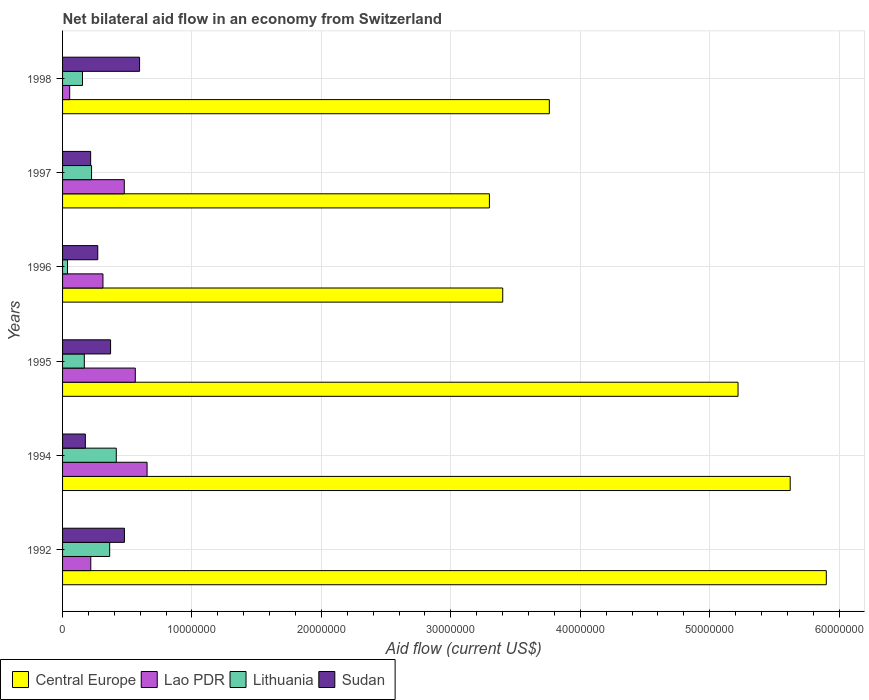How many different coloured bars are there?
Your answer should be compact. 4. How many bars are there on the 2nd tick from the bottom?
Provide a succinct answer. 4. What is the label of the 2nd group of bars from the top?
Offer a very short reply. 1997. In how many cases, is the number of bars for a given year not equal to the number of legend labels?
Provide a succinct answer. 0. What is the net bilateral aid flow in Lao PDR in 1992?
Your answer should be very brief. 2.18e+06. Across all years, what is the maximum net bilateral aid flow in Lithuania?
Provide a short and direct response. 4.15e+06. Across all years, what is the minimum net bilateral aid flow in Lithuania?
Provide a short and direct response. 3.80e+05. In which year was the net bilateral aid flow in Central Europe minimum?
Your answer should be compact. 1997. What is the total net bilateral aid flow in Lithuania in the graph?
Your answer should be very brief. 1.36e+07. What is the difference between the net bilateral aid flow in Sudan in 1992 and that in 1994?
Your answer should be compact. 3.02e+06. What is the difference between the net bilateral aid flow in Sudan in 1992 and the net bilateral aid flow in Lithuania in 1998?
Offer a very short reply. 3.24e+06. What is the average net bilateral aid flow in Central Europe per year?
Your answer should be compact. 4.53e+07. In the year 1996, what is the difference between the net bilateral aid flow in Sudan and net bilateral aid flow in Central Europe?
Provide a succinct answer. -3.13e+07. What is the ratio of the net bilateral aid flow in Lithuania in 1996 to that in 1998?
Your answer should be compact. 0.25. Is the net bilateral aid flow in Lithuania in 1997 less than that in 1998?
Your answer should be compact. No. What is the difference between the highest and the second highest net bilateral aid flow in Lao PDR?
Ensure brevity in your answer.  9.10e+05. What is the difference between the highest and the lowest net bilateral aid flow in Lao PDR?
Keep it short and to the point. 5.98e+06. Is the sum of the net bilateral aid flow in Lao PDR in 1995 and 1997 greater than the maximum net bilateral aid flow in Sudan across all years?
Your answer should be very brief. Yes. What does the 3rd bar from the top in 1997 represents?
Provide a short and direct response. Lao PDR. What does the 3rd bar from the bottom in 1996 represents?
Keep it short and to the point. Lithuania. How many bars are there?
Give a very brief answer. 24. What is the difference between two consecutive major ticks on the X-axis?
Keep it short and to the point. 1.00e+07. Are the values on the major ticks of X-axis written in scientific E-notation?
Make the answer very short. No. Does the graph contain grids?
Your answer should be very brief. Yes. What is the title of the graph?
Your answer should be compact. Net bilateral aid flow in an economy from Switzerland. What is the label or title of the X-axis?
Keep it short and to the point. Aid flow (current US$). What is the Aid flow (current US$) in Central Europe in 1992?
Offer a terse response. 5.90e+07. What is the Aid flow (current US$) in Lao PDR in 1992?
Your answer should be very brief. 2.18e+06. What is the Aid flow (current US$) of Lithuania in 1992?
Give a very brief answer. 3.64e+06. What is the Aid flow (current US$) of Sudan in 1992?
Offer a terse response. 4.78e+06. What is the Aid flow (current US$) of Central Europe in 1994?
Offer a very short reply. 5.62e+07. What is the Aid flow (current US$) of Lao PDR in 1994?
Your answer should be compact. 6.53e+06. What is the Aid flow (current US$) of Lithuania in 1994?
Your response must be concise. 4.15e+06. What is the Aid flow (current US$) of Sudan in 1994?
Your answer should be very brief. 1.76e+06. What is the Aid flow (current US$) in Central Europe in 1995?
Make the answer very short. 5.22e+07. What is the Aid flow (current US$) of Lao PDR in 1995?
Provide a short and direct response. 5.62e+06. What is the Aid flow (current US$) of Lithuania in 1995?
Provide a short and direct response. 1.68e+06. What is the Aid flow (current US$) in Sudan in 1995?
Offer a very short reply. 3.71e+06. What is the Aid flow (current US$) of Central Europe in 1996?
Provide a short and direct response. 3.40e+07. What is the Aid flow (current US$) of Lao PDR in 1996?
Keep it short and to the point. 3.12e+06. What is the Aid flow (current US$) in Lithuania in 1996?
Offer a terse response. 3.80e+05. What is the Aid flow (current US$) in Sudan in 1996?
Your answer should be very brief. 2.72e+06. What is the Aid flow (current US$) in Central Europe in 1997?
Provide a succinct answer. 3.30e+07. What is the Aid flow (current US$) of Lao PDR in 1997?
Provide a short and direct response. 4.77e+06. What is the Aid flow (current US$) in Lithuania in 1997?
Make the answer very short. 2.24e+06. What is the Aid flow (current US$) of Sudan in 1997?
Give a very brief answer. 2.17e+06. What is the Aid flow (current US$) of Central Europe in 1998?
Your answer should be very brief. 3.76e+07. What is the Aid flow (current US$) of Lithuania in 1998?
Offer a very short reply. 1.54e+06. What is the Aid flow (current US$) of Sudan in 1998?
Give a very brief answer. 5.95e+06. Across all years, what is the maximum Aid flow (current US$) in Central Europe?
Provide a succinct answer. 5.90e+07. Across all years, what is the maximum Aid flow (current US$) in Lao PDR?
Provide a succinct answer. 6.53e+06. Across all years, what is the maximum Aid flow (current US$) of Lithuania?
Your response must be concise. 4.15e+06. Across all years, what is the maximum Aid flow (current US$) of Sudan?
Give a very brief answer. 5.95e+06. Across all years, what is the minimum Aid flow (current US$) in Central Europe?
Your answer should be very brief. 3.30e+07. Across all years, what is the minimum Aid flow (current US$) of Lithuania?
Make the answer very short. 3.80e+05. Across all years, what is the minimum Aid flow (current US$) of Sudan?
Give a very brief answer. 1.76e+06. What is the total Aid flow (current US$) of Central Europe in the graph?
Your response must be concise. 2.72e+08. What is the total Aid flow (current US$) in Lao PDR in the graph?
Your answer should be compact. 2.28e+07. What is the total Aid flow (current US$) of Lithuania in the graph?
Your answer should be compact. 1.36e+07. What is the total Aid flow (current US$) in Sudan in the graph?
Your answer should be very brief. 2.11e+07. What is the difference between the Aid flow (current US$) of Central Europe in 1992 and that in 1994?
Keep it short and to the point. 2.79e+06. What is the difference between the Aid flow (current US$) in Lao PDR in 1992 and that in 1994?
Provide a succinct answer. -4.35e+06. What is the difference between the Aid flow (current US$) of Lithuania in 1992 and that in 1994?
Give a very brief answer. -5.10e+05. What is the difference between the Aid flow (current US$) in Sudan in 1992 and that in 1994?
Offer a very short reply. 3.02e+06. What is the difference between the Aid flow (current US$) of Central Europe in 1992 and that in 1995?
Your answer should be very brief. 6.82e+06. What is the difference between the Aid flow (current US$) in Lao PDR in 1992 and that in 1995?
Offer a terse response. -3.44e+06. What is the difference between the Aid flow (current US$) in Lithuania in 1992 and that in 1995?
Offer a terse response. 1.96e+06. What is the difference between the Aid flow (current US$) in Sudan in 1992 and that in 1995?
Your response must be concise. 1.07e+06. What is the difference between the Aid flow (current US$) in Central Europe in 1992 and that in 1996?
Your answer should be very brief. 2.50e+07. What is the difference between the Aid flow (current US$) in Lao PDR in 1992 and that in 1996?
Keep it short and to the point. -9.40e+05. What is the difference between the Aid flow (current US$) of Lithuania in 1992 and that in 1996?
Make the answer very short. 3.26e+06. What is the difference between the Aid flow (current US$) in Sudan in 1992 and that in 1996?
Give a very brief answer. 2.06e+06. What is the difference between the Aid flow (current US$) in Central Europe in 1992 and that in 1997?
Offer a terse response. 2.60e+07. What is the difference between the Aid flow (current US$) of Lao PDR in 1992 and that in 1997?
Ensure brevity in your answer.  -2.59e+06. What is the difference between the Aid flow (current US$) of Lithuania in 1992 and that in 1997?
Keep it short and to the point. 1.40e+06. What is the difference between the Aid flow (current US$) in Sudan in 1992 and that in 1997?
Provide a succinct answer. 2.61e+06. What is the difference between the Aid flow (current US$) in Central Europe in 1992 and that in 1998?
Make the answer very short. 2.14e+07. What is the difference between the Aid flow (current US$) in Lao PDR in 1992 and that in 1998?
Offer a very short reply. 1.63e+06. What is the difference between the Aid flow (current US$) of Lithuania in 1992 and that in 1998?
Offer a very short reply. 2.10e+06. What is the difference between the Aid flow (current US$) in Sudan in 1992 and that in 1998?
Give a very brief answer. -1.17e+06. What is the difference between the Aid flow (current US$) in Central Europe in 1994 and that in 1995?
Make the answer very short. 4.03e+06. What is the difference between the Aid flow (current US$) in Lao PDR in 1994 and that in 1995?
Your answer should be very brief. 9.10e+05. What is the difference between the Aid flow (current US$) in Lithuania in 1994 and that in 1995?
Make the answer very short. 2.47e+06. What is the difference between the Aid flow (current US$) in Sudan in 1994 and that in 1995?
Give a very brief answer. -1.95e+06. What is the difference between the Aid flow (current US$) in Central Europe in 1994 and that in 1996?
Offer a terse response. 2.22e+07. What is the difference between the Aid flow (current US$) in Lao PDR in 1994 and that in 1996?
Keep it short and to the point. 3.41e+06. What is the difference between the Aid flow (current US$) in Lithuania in 1994 and that in 1996?
Your answer should be very brief. 3.77e+06. What is the difference between the Aid flow (current US$) in Sudan in 1994 and that in 1996?
Offer a terse response. -9.60e+05. What is the difference between the Aid flow (current US$) of Central Europe in 1994 and that in 1997?
Give a very brief answer. 2.32e+07. What is the difference between the Aid flow (current US$) of Lao PDR in 1994 and that in 1997?
Provide a short and direct response. 1.76e+06. What is the difference between the Aid flow (current US$) in Lithuania in 1994 and that in 1997?
Offer a terse response. 1.91e+06. What is the difference between the Aid flow (current US$) in Sudan in 1994 and that in 1997?
Your answer should be very brief. -4.10e+05. What is the difference between the Aid flow (current US$) of Central Europe in 1994 and that in 1998?
Your response must be concise. 1.86e+07. What is the difference between the Aid flow (current US$) in Lao PDR in 1994 and that in 1998?
Offer a very short reply. 5.98e+06. What is the difference between the Aid flow (current US$) in Lithuania in 1994 and that in 1998?
Make the answer very short. 2.61e+06. What is the difference between the Aid flow (current US$) in Sudan in 1994 and that in 1998?
Provide a succinct answer. -4.19e+06. What is the difference between the Aid flow (current US$) in Central Europe in 1995 and that in 1996?
Offer a very short reply. 1.82e+07. What is the difference between the Aid flow (current US$) of Lao PDR in 1995 and that in 1996?
Ensure brevity in your answer.  2.50e+06. What is the difference between the Aid flow (current US$) of Lithuania in 1995 and that in 1996?
Offer a very short reply. 1.30e+06. What is the difference between the Aid flow (current US$) of Sudan in 1995 and that in 1996?
Your response must be concise. 9.90e+05. What is the difference between the Aid flow (current US$) in Central Europe in 1995 and that in 1997?
Your answer should be compact. 1.92e+07. What is the difference between the Aid flow (current US$) in Lao PDR in 1995 and that in 1997?
Provide a succinct answer. 8.50e+05. What is the difference between the Aid flow (current US$) of Lithuania in 1995 and that in 1997?
Make the answer very short. -5.60e+05. What is the difference between the Aid flow (current US$) in Sudan in 1995 and that in 1997?
Offer a very short reply. 1.54e+06. What is the difference between the Aid flow (current US$) in Central Europe in 1995 and that in 1998?
Ensure brevity in your answer.  1.46e+07. What is the difference between the Aid flow (current US$) of Lao PDR in 1995 and that in 1998?
Your response must be concise. 5.07e+06. What is the difference between the Aid flow (current US$) in Sudan in 1995 and that in 1998?
Your answer should be very brief. -2.24e+06. What is the difference between the Aid flow (current US$) of Central Europe in 1996 and that in 1997?
Offer a very short reply. 1.03e+06. What is the difference between the Aid flow (current US$) in Lao PDR in 1996 and that in 1997?
Your answer should be compact. -1.65e+06. What is the difference between the Aid flow (current US$) of Lithuania in 1996 and that in 1997?
Make the answer very short. -1.86e+06. What is the difference between the Aid flow (current US$) of Central Europe in 1996 and that in 1998?
Give a very brief answer. -3.60e+06. What is the difference between the Aid flow (current US$) of Lao PDR in 1996 and that in 1998?
Make the answer very short. 2.57e+06. What is the difference between the Aid flow (current US$) in Lithuania in 1996 and that in 1998?
Ensure brevity in your answer.  -1.16e+06. What is the difference between the Aid flow (current US$) in Sudan in 1996 and that in 1998?
Your answer should be very brief. -3.23e+06. What is the difference between the Aid flow (current US$) in Central Europe in 1997 and that in 1998?
Give a very brief answer. -4.63e+06. What is the difference between the Aid flow (current US$) in Lao PDR in 1997 and that in 1998?
Your answer should be compact. 4.22e+06. What is the difference between the Aid flow (current US$) of Sudan in 1997 and that in 1998?
Offer a terse response. -3.78e+06. What is the difference between the Aid flow (current US$) of Central Europe in 1992 and the Aid flow (current US$) of Lao PDR in 1994?
Your answer should be very brief. 5.25e+07. What is the difference between the Aid flow (current US$) in Central Europe in 1992 and the Aid flow (current US$) in Lithuania in 1994?
Your response must be concise. 5.49e+07. What is the difference between the Aid flow (current US$) in Central Europe in 1992 and the Aid flow (current US$) in Sudan in 1994?
Your answer should be compact. 5.72e+07. What is the difference between the Aid flow (current US$) of Lao PDR in 1992 and the Aid flow (current US$) of Lithuania in 1994?
Ensure brevity in your answer.  -1.97e+06. What is the difference between the Aid flow (current US$) of Lao PDR in 1992 and the Aid flow (current US$) of Sudan in 1994?
Your answer should be compact. 4.20e+05. What is the difference between the Aid flow (current US$) of Lithuania in 1992 and the Aid flow (current US$) of Sudan in 1994?
Ensure brevity in your answer.  1.88e+06. What is the difference between the Aid flow (current US$) in Central Europe in 1992 and the Aid flow (current US$) in Lao PDR in 1995?
Your answer should be compact. 5.34e+07. What is the difference between the Aid flow (current US$) of Central Europe in 1992 and the Aid flow (current US$) of Lithuania in 1995?
Keep it short and to the point. 5.73e+07. What is the difference between the Aid flow (current US$) of Central Europe in 1992 and the Aid flow (current US$) of Sudan in 1995?
Offer a terse response. 5.53e+07. What is the difference between the Aid flow (current US$) in Lao PDR in 1992 and the Aid flow (current US$) in Lithuania in 1995?
Offer a terse response. 5.00e+05. What is the difference between the Aid flow (current US$) in Lao PDR in 1992 and the Aid flow (current US$) in Sudan in 1995?
Your answer should be compact. -1.53e+06. What is the difference between the Aid flow (current US$) in Central Europe in 1992 and the Aid flow (current US$) in Lao PDR in 1996?
Your response must be concise. 5.59e+07. What is the difference between the Aid flow (current US$) of Central Europe in 1992 and the Aid flow (current US$) of Lithuania in 1996?
Give a very brief answer. 5.86e+07. What is the difference between the Aid flow (current US$) in Central Europe in 1992 and the Aid flow (current US$) in Sudan in 1996?
Your answer should be compact. 5.63e+07. What is the difference between the Aid flow (current US$) in Lao PDR in 1992 and the Aid flow (current US$) in Lithuania in 1996?
Make the answer very short. 1.80e+06. What is the difference between the Aid flow (current US$) in Lao PDR in 1992 and the Aid flow (current US$) in Sudan in 1996?
Your response must be concise. -5.40e+05. What is the difference between the Aid flow (current US$) of Lithuania in 1992 and the Aid flow (current US$) of Sudan in 1996?
Keep it short and to the point. 9.20e+05. What is the difference between the Aid flow (current US$) of Central Europe in 1992 and the Aid flow (current US$) of Lao PDR in 1997?
Your answer should be very brief. 5.42e+07. What is the difference between the Aid flow (current US$) of Central Europe in 1992 and the Aid flow (current US$) of Lithuania in 1997?
Offer a very short reply. 5.68e+07. What is the difference between the Aid flow (current US$) in Central Europe in 1992 and the Aid flow (current US$) in Sudan in 1997?
Provide a succinct answer. 5.68e+07. What is the difference between the Aid flow (current US$) of Lithuania in 1992 and the Aid flow (current US$) of Sudan in 1997?
Make the answer very short. 1.47e+06. What is the difference between the Aid flow (current US$) of Central Europe in 1992 and the Aid flow (current US$) of Lao PDR in 1998?
Make the answer very short. 5.85e+07. What is the difference between the Aid flow (current US$) in Central Europe in 1992 and the Aid flow (current US$) in Lithuania in 1998?
Provide a short and direct response. 5.75e+07. What is the difference between the Aid flow (current US$) in Central Europe in 1992 and the Aid flow (current US$) in Sudan in 1998?
Make the answer very short. 5.31e+07. What is the difference between the Aid flow (current US$) of Lao PDR in 1992 and the Aid flow (current US$) of Lithuania in 1998?
Give a very brief answer. 6.40e+05. What is the difference between the Aid flow (current US$) of Lao PDR in 1992 and the Aid flow (current US$) of Sudan in 1998?
Give a very brief answer. -3.77e+06. What is the difference between the Aid flow (current US$) in Lithuania in 1992 and the Aid flow (current US$) in Sudan in 1998?
Give a very brief answer. -2.31e+06. What is the difference between the Aid flow (current US$) in Central Europe in 1994 and the Aid flow (current US$) in Lao PDR in 1995?
Provide a succinct answer. 5.06e+07. What is the difference between the Aid flow (current US$) of Central Europe in 1994 and the Aid flow (current US$) of Lithuania in 1995?
Offer a very short reply. 5.45e+07. What is the difference between the Aid flow (current US$) of Central Europe in 1994 and the Aid flow (current US$) of Sudan in 1995?
Offer a very short reply. 5.25e+07. What is the difference between the Aid flow (current US$) of Lao PDR in 1994 and the Aid flow (current US$) of Lithuania in 1995?
Your response must be concise. 4.85e+06. What is the difference between the Aid flow (current US$) of Lao PDR in 1994 and the Aid flow (current US$) of Sudan in 1995?
Provide a succinct answer. 2.82e+06. What is the difference between the Aid flow (current US$) in Central Europe in 1994 and the Aid flow (current US$) in Lao PDR in 1996?
Keep it short and to the point. 5.31e+07. What is the difference between the Aid flow (current US$) of Central Europe in 1994 and the Aid flow (current US$) of Lithuania in 1996?
Provide a succinct answer. 5.58e+07. What is the difference between the Aid flow (current US$) in Central Europe in 1994 and the Aid flow (current US$) in Sudan in 1996?
Make the answer very short. 5.35e+07. What is the difference between the Aid flow (current US$) in Lao PDR in 1994 and the Aid flow (current US$) in Lithuania in 1996?
Provide a short and direct response. 6.15e+06. What is the difference between the Aid flow (current US$) of Lao PDR in 1994 and the Aid flow (current US$) of Sudan in 1996?
Your answer should be very brief. 3.81e+06. What is the difference between the Aid flow (current US$) of Lithuania in 1994 and the Aid flow (current US$) of Sudan in 1996?
Make the answer very short. 1.43e+06. What is the difference between the Aid flow (current US$) of Central Europe in 1994 and the Aid flow (current US$) of Lao PDR in 1997?
Your answer should be very brief. 5.14e+07. What is the difference between the Aid flow (current US$) of Central Europe in 1994 and the Aid flow (current US$) of Lithuania in 1997?
Give a very brief answer. 5.40e+07. What is the difference between the Aid flow (current US$) of Central Europe in 1994 and the Aid flow (current US$) of Sudan in 1997?
Offer a terse response. 5.40e+07. What is the difference between the Aid flow (current US$) of Lao PDR in 1994 and the Aid flow (current US$) of Lithuania in 1997?
Your answer should be very brief. 4.29e+06. What is the difference between the Aid flow (current US$) in Lao PDR in 1994 and the Aid flow (current US$) in Sudan in 1997?
Offer a terse response. 4.36e+06. What is the difference between the Aid flow (current US$) of Lithuania in 1994 and the Aid flow (current US$) of Sudan in 1997?
Provide a succinct answer. 1.98e+06. What is the difference between the Aid flow (current US$) in Central Europe in 1994 and the Aid flow (current US$) in Lao PDR in 1998?
Offer a very short reply. 5.57e+07. What is the difference between the Aid flow (current US$) of Central Europe in 1994 and the Aid flow (current US$) of Lithuania in 1998?
Make the answer very short. 5.47e+07. What is the difference between the Aid flow (current US$) in Central Europe in 1994 and the Aid flow (current US$) in Sudan in 1998?
Provide a short and direct response. 5.03e+07. What is the difference between the Aid flow (current US$) of Lao PDR in 1994 and the Aid flow (current US$) of Lithuania in 1998?
Make the answer very short. 4.99e+06. What is the difference between the Aid flow (current US$) in Lao PDR in 1994 and the Aid flow (current US$) in Sudan in 1998?
Offer a terse response. 5.80e+05. What is the difference between the Aid flow (current US$) in Lithuania in 1994 and the Aid flow (current US$) in Sudan in 1998?
Offer a very short reply. -1.80e+06. What is the difference between the Aid flow (current US$) in Central Europe in 1995 and the Aid flow (current US$) in Lao PDR in 1996?
Offer a terse response. 4.91e+07. What is the difference between the Aid flow (current US$) of Central Europe in 1995 and the Aid flow (current US$) of Lithuania in 1996?
Ensure brevity in your answer.  5.18e+07. What is the difference between the Aid flow (current US$) in Central Europe in 1995 and the Aid flow (current US$) in Sudan in 1996?
Provide a succinct answer. 4.95e+07. What is the difference between the Aid flow (current US$) of Lao PDR in 1995 and the Aid flow (current US$) of Lithuania in 1996?
Give a very brief answer. 5.24e+06. What is the difference between the Aid flow (current US$) of Lao PDR in 1995 and the Aid flow (current US$) of Sudan in 1996?
Provide a succinct answer. 2.90e+06. What is the difference between the Aid flow (current US$) in Lithuania in 1995 and the Aid flow (current US$) in Sudan in 1996?
Provide a short and direct response. -1.04e+06. What is the difference between the Aid flow (current US$) in Central Europe in 1995 and the Aid flow (current US$) in Lao PDR in 1997?
Offer a terse response. 4.74e+07. What is the difference between the Aid flow (current US$) in Central Europe in 1995 and the Aid flow (current US$) in Lithuania in 1997?
Your answer should be compact. 5.00e+07. What is the difference between the Aid flow (current US$) of Central Europe in 1995 and the Aid flow (current US$) of Sudan in 1997?
Give a very brief answer. 5.00e+07. What is the difference between the Aid flow (current US$) in Lao PDR in 1995 and the Aid flow (current US$) in Lithuania in 1997?
Provide a succinct answer. 3.38e+06. What is the difference between the Aid flow (current US$) in Lao PDR in 1995 and the Aid flow (current US$) in Sudan in 1997?
Keep it short and to the point. 3.45e+06. What is the difference between the Aid flow (current US$) in Lithuania in 1995 and the Aid flow (current US$) in Sudan in 1997?
Your answer should be compact. -4.90e+05. What is the difference between the Aid flow (current US$) in Central Europe in 1995 and the Aid flow (current US$) in Lao PDR in 1998?
Provide a short and direct response. 5.16e+07. What is the difference between the Aid flow (current US$) of Central Europe in 1995 and the Aid flow (current US$) of Lithuania in 1998?
Offer a terse response. 5.06e+07. What is the difference between the Aid flow (current US$) of Central Europe in 1995 and the Aid flow (current US$) of Sudan in 1998?
Offer a very short reply. 4.62e+07. What is the difference between the Aid flow (current US$) of Lao PDR in 1995 and the Aid flow (current US$) of Lithuania in 1998?
Give a very brief answer. 4.08e+06. What is the difference between the Aid flow (current US$) of Lao PDR in 1995 and the Aid flow (current US$) of Sudan in 1998?
Offer a very short reply. -3.30e+05. What is the difference between the Aid flow (current US$) in Lithuania in 1995 and the Aid flow (current US$) in Sudan in 1998?
Ensure brevity in your answer.  -4.27e+06. What is the difference between the Aid flow (current US$) in Central Europe in 1996 and the Aid flow (current US$) in Lao PDR in 1997?
Your answer should be very brief. 2.92e+07. What is the difference between the Aid flow (current US$) in Central Europe in 1996 and the Aid flow (current US$) in Lithuania in 1997?
Your response must be concise. 3.18e+07. What is the difference between the Aid flow (current US$) in Central Europe in 1996 and the Aid flow (current US$) in Sudan in 1997?
Make the answer very short. 3.18e+07. What is the difference between the Aid flow (current US$) of Lao PDR in 1996 and the Aid flow (current US$) of Lithuania in 1997?
Ensure brevity in your answer.  8.80e+05. What is the difference between the Aid flow (current US$) in Lao PDR in 1996 and the Aid flow (current US$) in Sudan in 1997?
Ensure brevity in your answer.  9.50e+05. What is the difference between the Aid flow (current US$) in Lithuania in 1996 and the Aid flow (current US$) in Sudan in 1997?
Offer a very short reply. -1.79e+06. What is the difference between the Aid flow (current US$) of Central Europe in 1996 and the Aid flow (current US$) of Lao PDR in 1998?
Keep it short and to the point. 3.35e+07. What is the difference between the Aid flow (current US$) in Central Europe in 1996 and the Aid flow (current US$) in Lithuania in 1998?
Ensure brevity in your answer.  3.25e+07. What is the difference between the Aid flow (current US$) in Central Europe in 1996 and the Aid flow (current US$) in Sudan in 1998?
Your answer should be very brief. 2.81e+07. What is the difference between the Aid flow (current US$) in Lao PDR in 1996 and the Aid flow (current US$) in Lithuania in 1998?
Offer a terse response. 1.58e+06. What is the difference between the Aid flow (current US$) of Lao PDR in 1996 and the Aid flow (current US$) of Sudan in 1998?
Provide a short and direct response. -2.83e+06. What is the difference between the Aid flow (current US$) in Lithuania in 1996 and the Aid flow (current US$) in Sudan in 1998?
Provide a short and direct response. -5.57e+06. What is the difference between the Aid flow (current US$) in Central Europe in 1997 and the Aid flow (current US$) in Lao PDR in 1998?
Offer a terse response. 3.24e+07. What is the difference between the Aid flow (current US$) of Central Europe in 1997 and the Aid flow (current US$) of Lithuania in 1998?
Offer a terse response. 3.14e+07. What is the difference between the Aid flow (current US$) in Central Europe in 1997 and the Aid flow (current US$) in Sudan in 1998?
Offer a terse response. 2.70e+07. What is the difference between the Aid flow (current US$) of Lao PDR in 1997 and the Aid flow (current US$) of Lithuania in 1998?
Make the answer very short. 3.23e+06. What is the difference between the Aid flow (current US$) in Lao PDR in 1997 and the Aid flow (current US$) in Sudan in 1998?
Provide a short and direct response. -1.18e+06. What is the difference between the Aid flow (current US$) in Lithuania in 1997 and the Aid flow (current US$) in Sudan in 1998?
Your answer should be very brief. -3.71e+06. What is the average Aid flow (current US$) in Central Europe per year?
Provide a succinct answer. 4.53e+07. What is the average Aid flow (current US$) in Lao PDR per year?
Make the answer very short. 3.80e+06. What is the average Aid flow (current US$) in Lithuania per year?
Offer a very short reply. 2.27e+06. What is the average Aid flow (current US$) in Sudan per year?
Your answer should be very brief. 3.52e+06. In the year 1992, what is the difference between the Aid flow (current US$) of Central Europe and Aid flow (current US$) of Lao PDR?
Give a very brief answer. 5.68e+07. In the year 1992, what is the difference between the Aid flow (current US$) in Central Europe and Aid flow (current US$) in Lithuania?
Your answer should be compact. 5.54e+07. In the year 1992, what is the difference between the Aid flow (current US$) of Central Europe and Aid flow (current US$) of Sudan?
Your answer should be compact. 5.42e+07. In the year 1992, what is the difference between the Aid flow (current US$) in Lao PDR and Aid flow (current US$) in Lithuania?
Provide a succinct answer. -1.46e+06. In the year 1992, what is the difference between the Aid flow (current US$) in Lao PDR and Aid flow (current US$) in Sudan?
Your answer should be very brief. -2.60e+06. In the year 1992, what is the difference between the Aid flow (current US$) of Lithuania and Aid flow (current US$) of Sudan?
Offer a very short reply. -1.14e+06. In the year 1994, what is the difference between the Aid flow (current US$) of Central Europe and Aid flow (current US$) of Lao PDR?
Offer a terse response. 4.97e+07. In the year 1994, what is the difference between the Aid flow (current US$) in Central Europe and Aid flow (current US$) in Lithuania?
Make the answer very short. 5.21e+07. In the year 1994, what is the difference between the Aid flow (current US$) of Central Europe and Aid flow (current US$) of Sudan?
Your response must be concise. 5.45e+07. In the year 1994, what is the difference between the Aid flow (current US$) in Lao PDR and Aid flow (current US$) in Lithuania?
Provide a short and direct response. 2.38e+06. In the year 1994, what is the difference between the Aid flow (current US$) in Lao PDR and Aid flow (current US$) in Sudan?
Your answer should be compact. 4.77e+06. In the year 1994, what is the difference between the Aid flow (current US$) of Lithuania and Aid flow (current US$) of Sudan?
Give a very brief answer. 2.39e+06. In the year 1995, what is the difference between the Aid flow (current US$) in Central Europe and Aid flow (current US$) in Lao PDR?
Ensure brevity in your answer.  4.66e+07. In the year 1995, what is the difference between the Aid flow (current US$) in Central Europe and Aid flow (current US$) in Lithuania?
Offer a terse response. 5.05e+07. In the year 1995, what is the difference between the Aid flow (current US$) in Central Europe and Aid flow (current US$) in Sudan?
Keep it short and to the point. 4.85e+07. In the year 1995, what is the difference between the Aid flow (current US$) in Lao PDR and Aid flow (current US$) in Lithuania?
Provide a succinct answer. 3.94e+06. In the year 1995, what is the difference between the Aid flow (current US$) in Lao PDR and Aid flow (current US$) in Sudan?
Provide a succinct answer. 1.91e+06. In the year 1995, what is the difference between the Aid flow (current US$) of Lithuania and Aid flow (current US$) of Sudan?
Offer a very short reply. -2.03e+06. In the year 1996, what is the difference between the Aid flow (current US$) of Central Europe and Aid flow (current US$) of Lao PDR?
Your response must be concise. 3.09e+07. In the year 1996, what is the difference between the Aid flow (current US$) in Central Europe and Aid flow (current US$) in Lithuania?
Offer a very short reply. 3.36e+07. In the year 1996, what is the difference between the Aid flow (current US$) in Central Europe and Aid flow (current US$) in Sudan?
Provide a succinct answer. 3.13e+07. In the year 1996, what is the difference between the Aid flow (current US$) in Lao PDR and Aid flow (current US$) in Lithuania?
Ensure brevity in your answer.  2.74e+06. In the year 1996, what is the difference between the Aid flow (current US$) in Lao PDR and Aid flow (current US$) in Sudan?
Give a very brief answer. 4.00e+05. In the year 1996, what is the difference between the Aid flow (current US$) of Lithuania and Aid flow (current US$) of Sudan?
Provide a succinct answer. -2.34e+06. In the year 1997, what is the difference between the Aid flow (current US$) of Central Europe and Aid flow (current US$) of Lao PDR?
Make the answer very short. 2.82e+07. In the year 1997, what is the difference between the Aid flow (current US$) of Central Europe and Aid flow (current US$) of Lithuania?
Make the answer very short. 3.07e+07. In the year 1997, what is the difference between the Aid flow (current US$) of Central Europe and Aid flow (current US$) of Sudan?
Make the answer very short. 3.08e+07. In the year 1997, what is the difference between the Aid flow (current US$) of Lao PDR and Aid flow (current US$) of Lithuania?
Your answer should be very brief. 2.53e+06. In the year 1997, what is the difference between the Aid flow (current US$) of Lao PDR and Aid flow (current US$) of Sudan?
Make the answer very short. 2.60e+06. In the year 1998, what is the difference between the Aid flow (current US$) in Central Europe and Aid flow (current US$) in Lao PDR?
Provide a succinct answer. 3.71e+07. In the year 1998, what is the difference between the Aid flow (current US$) in Central Europe and Aid flow (current US$) in Lithuania?
Ensure brevity in your answer.  3.61e+07. In the year 1998, what is the difference between the Aid flow (current US$) of Central Europe and Aid flow (current US$) of Sudan?
Your answer should be very brief. 3.17e+07. In the year 1998, what is the difference between the Aid flow (current US$) of Lao PDR and Aid flow (current US$) of Lithuania?
Ensure brevity in your answer.  -9.90e+05. In the year 1998, what is the difference between the Aid flow (current US$) in Lao PDR and Aid flow (current US$) in Sudan?
Your answer should be compact. -5.40e+06. In the year 1998, what is the difference between the Aid flow (current US$) in Lithuania and Aid flow (current US$) in Sudan?
Your answer should be very brief. -4.41e+06. What is the ratio of the Aid flow (current US$) of Central Europe in 1992 to that in 1994?
Your response must be concise. 1.05. What is the ratio of the Aid flow (current US$) in Lao PDR in 1992 to that in 1994?
Give a very brief answer. 0.33. What is the ratio of the Aid flow (current US$) of Lithuania in 1992 to that in 1994?
Offer a terse response. 0.88. What is the ratio of the Aid flow (current US$) of Sudan in 1992 to that in 1994?
Ensure brevity in your answer.  2.72. What is the ratio of the Aid flow (current US$) in Central Europe in 1992 to that in 1995?
Provide a succinct answer. 1.13. What is the ratio of the Aid flow (current US$) of Lao PDR in 1992 to that in 1995?
Your response must be concise. 0.39. What is the ratio of the Aid flow (current US$) in Lithuania in 1992 to that in 1995?
Provide a succinct answer. 2.17. What is the ratio of the Aid flow (current US$) in Sudan in 1992 to that in 1995?
Offer a terse response. 1.29. What is the ratio of the Aid flow (current US$) in Central Europe in 1992 to that in 1996?
Give a very brief answer. 1.74. What is the ratio of the Aid flow (current US$) of Lao PDR in 1992 to that in 1996?
Provide a short and direct response. 0.7. What is the ratio of the Aid flow (current US$) of Lithuania in 1992 to that in 1996?
Offer a very short reply. 9.58. What is the ratio of the Aid flow (current US$) in Sudan in 1992 to that in 1996?
Offer a very short reply. 1.76. What is the ratio of the Aid flow (current US$) of Central Europe in 1992 to that in 1997?
Make the answer very short. 1.79. What is the ratio of the Aid flow (current US$) of Lao PDR in 1992 to that in 1997?
Offer a very short reply. 0.46. What is the ratio of the Aid flow (current US$) of Lithuania in 1992 to that in 1997?
Offer a very short reply. 1.62. What is the ratio of the Aid flow (current US$) of Sudan in 1992 to that in 1997?
Offer a terse response. 2.2. What is the ratio of the Aid flow (current US$) of Central Europe in 1992 to that in 1998?
Provide a short and direct response. 1.57. What is the ratio of the Aid flow (current US$) of Lao PDR in 1992 to that in 1998?
Your response must be concise. 3.96. What is the ratio of the Aid flow (current US$) in Lithuania in 1992 to that in 1998?
Give a very brief answer. 2.36. What is the ratio of the Aid flow (current US$) of Sudan in 1992 to that in 1998?
Provide a short and direct response. 0.8. What is the ratio of the Aid flow (current US$) in Central Europe in 1994 to that in 1995?
Your answer should be very brief. 1.08. What is the ratio of the Aid flow (current US$) in Lao PDR in 1994 to that in 1995?
Offer a very short reply. 1.16. What is the ratio of the Aid flow (current US$) in Lithuania in 1994 to that in 1995?
Provide a short and direct response. 2.47. What is the ratio of the Aid flow (current US$) of Sudan in 1994 to that in 1995?
Keep it short and to the point. 0.47. What is the ratio of the Aid flow (current US$) of Central Europe in 1994 to that in 1996?
Offer a terse response. 1.65. What is the ratio of the Aid flow (current US$) of Lao PDR in 1994 to that in 1996?
Ensure brevity in your answer.  2.09. What is the ratio of the Aid flow (current US$) in Lithuania in 1994 to that in 1996?
Your answer should be very brief. 10.92. What is the ratio of the Aid flow (current US$) of Sudan in 1994 to that in 1996?
Ensure brevity in your answer.  0.65. What is the ratio of the Aid flow (current US$) of Central Europe in 1994 to that in 1997?
Keep it short and to the point. 1.7. What is the ratio of the Aid flow (current US$) in Lao PDR in 1994 to that in 1997?
Ensure brevity in your answer.  1.37. What is the ratio of the Aid flow (current US$) in Lithuania in 1994 to that in 1997?
Provide a succinct answer. 1.85. What is the ratio of the Aid flow (current US$) of Sudan in 1994 to that in 1997?
Provide a succinct answer. 0.81. What is the ratio of the Aid flow (current US$) of Central Europe in 1994 to that in 1998?
Offer a terse response. 1.49. What is the ratio of the Aid flow (current US$) in Lao PDR in 1994 to that in 1998?
Provide a short and direct response. 11.87. What is the ratio of the Aid flow (current US$) of Lithuania in 1994 to that in 1998?
Provide a short and direct response. 2.69. What is the ratio of the Aid flow (current US$) of Sudan in 1994 to that in 1998?
Ensure brevity in your answer.  0.3. What is the ratio of the Aid flow (current US$) of Central Europe in 1995 to that in 1996?
Ensure brevity in your answer.  1.53. What is the ratio of the Aid flow (current US$) in Lao PDR in 1995 to that in 1996?
Your answer should be very brief. 1.8. What is the ratio of the Aid flow (current US$) in Lithuania in 1995 to that in 1996?
Make the answer very short. 4.42. What is the ratio of the Aid flow (current US$) of Sudan in 1995 to that in 1996?
Offer a terse response. 1.36. What is the ratio of the Aid flow (current US$) of Central Europe in 1995 to that in 1997?
Give a very brief answer. 1.58. What is the ratio of the Aid flow (current US$) of Lao PDR in 1995 to that in 1997?
Make the answer very short. 1.18. What is the ratio of the Aid flow (current US$) of Sudan in 1995 to that in 1997?
Keep it short and to the point. 1.71. What is the ratio of the Aid flow (current US$) of Central Europe in 1995 to that in 1998?
Give a very brief answer. 1.39. What is the ratio of the Aid flow (current US$) of Lao PDR in 1995 to that in 1998?
Offer a terse response. 10.22. What is the ratio of the Aid flow (current US$) in Sudan in 1995 to that in 1998?
Offer a terse response. 0.62. What is the ratio of the Aid flow (current US$) in Central Europe in 1996 to that in 1997?
Your response must be concise. 1.03. What is the ratio of the Aid flow (current US$) in Lao PDR in 1996 to that in 1997?
Your answer should be very brief. 0.65. What is the ratio of the Aid flow (current US$) in Lithuania in 1996 to that in 1997?
Offer a very short reply. 0.17. What is the ratio of the Aid flow (current US$) of Sudan in 1996 to that in 1997?
Offer a very short reply. 1.25. What is the ratio of the Aid flow (current US$) in Central Europe in 1996 to that in 1998?
Provide a short and direct response. 0.9. What is the ratio of the Aid flow (current US$) of Lao PDR in 1996 to that in 1998?
Your answer should be compact. 5.67. What is the ratio of the Aid flow (current US$) of Lithuania in 1996 to that in 1998?
Offer a very short reply. 0.25. What is the ratio of the Aid flow (current US$) in Sudan in 1996 to that in 1998?
Make the answer very short. 0.46. What is the ratio of the Aid flow (current US$) of Central Europe in 1997 to that in 1998?
Your answer should be very brief. 0.88. What is the ratio of the Aid flow (current US$) in Lao PDR in 1997 to that in 1998?
Make the answer very short. 8.67. What is the ratio of the Aid flow (current US$) in Lithuania in 1997 to that in 1998?
Your answer should be very brief. 1.45. What is the ratio of the Aid flow (current US$) in Sudan in 1997 to that in 1998?
Ensure brevity in your answer.  0.36. What is the difference between the highest and the second highest Aid flow (current US$) in Central Europe?
Your answer should be very brief. 2.79e+06. What is the difference between the highest and the second highest Aid flow (current US$) in Lao PDR?
Offer a terse response. 9.10e+05. What is the difference between the highest and the second highest Aid flow (current US$) of Lithuania?
Offer a very short reply. 5.10e+05. What is the difference between the highest and the second highest Aid flow (current US$) of Sudan?
Provide a short and direct response. 1.17e+06. What is the difference between the highest and the lowest Aid flow (current US$) of Central Europe?
Your response must be concise. 2.60e+07. What is the difference between the highest and the lowest Aid flow (current US$) of Lao PDR?
Your answer should be compact. 5.98e+06. What is the difference between the highest and the lowest Aid flow (current US$) of Lithuania?
Provide a succinct answer. 3.77e+06. What is the difference between the highest and the lowest Aid flow (current US$) in Sudan?
Offer a terse response. 4.19e+06. 